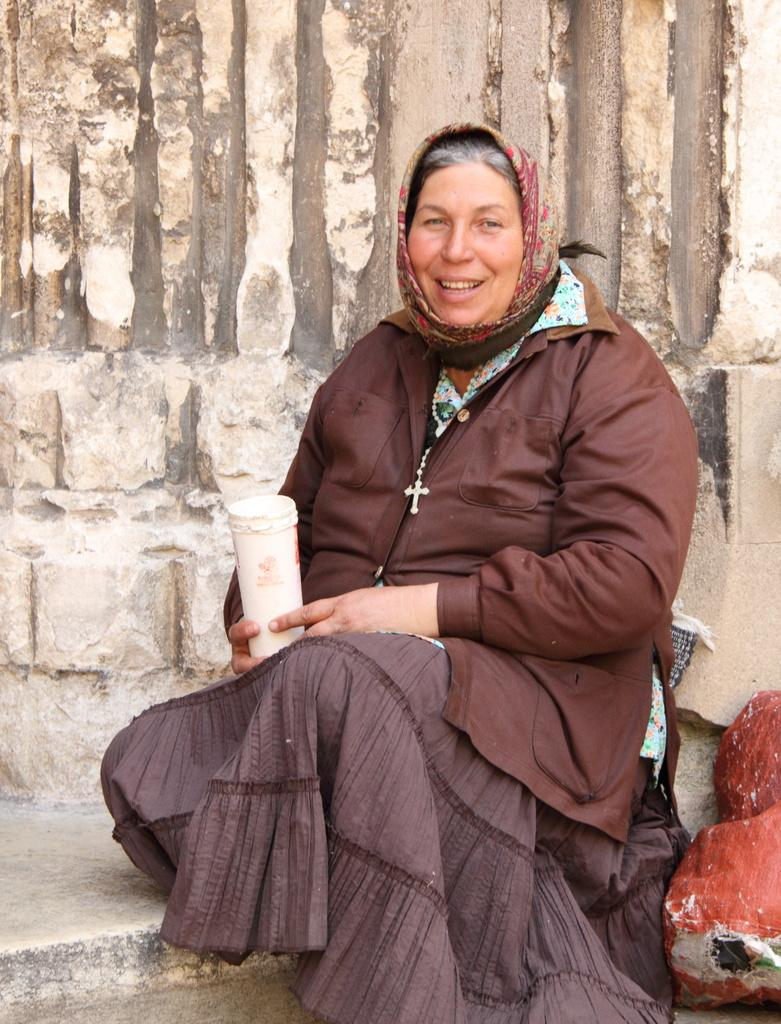Who is present in the image? There is a woman in the image. What is the woman doing in the image? The woman is sitting and holding a bottle. What is the woman's facial expression in the image? The woman is smiling in the image. What can be seen behind the woman in the image? There is a wall visible behind the woman. What type of powder is the woman requesting from the tramp in the image? There is no tramp or powder present in the image. 